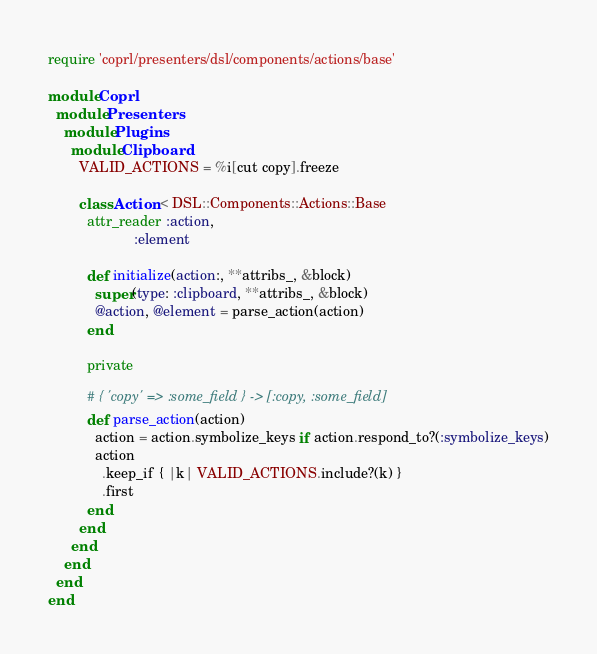<code> <loc_0><loc_0><loc_500><loc_500><_Ruby_>require 'coprl/presenters/dsl/components/actions/base'

module Coprl
  module Presenters
    module Plugins
      module Clipboard
        VALID_ACTIONS = %i[cut copy].freeze

        class Action < DSL::Components::Actions::Base
          attr_reader :action,
                      :element

          def initialize(action:, **attribs_, &block)
            super(type: :clipboard, **attribs_, &block)
            @action, @element = parse_action(action)
          end

          private

          # { 'copy' => :some_field } -> [:copy, :some_field]
          def parse_action(action)
            action = action.symbolize_keys if action.respond_to?(:symbolize_keys)
            action
              .keep_if { |k| VALID_ACTIONS.include?(k) }
              .first
          end
        end
      end
    end
  end
end
</code> 